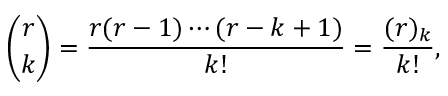<formula> <loc_0><loc_0><loc_500><loc_500>{ \binom { r } { k } } = { \frac { r ( r - 1 ) \cdots ( r - k + 1 ) } { k ! } } = { \frac { ( r ) _ { k } } { k ! } } ,</formula> 